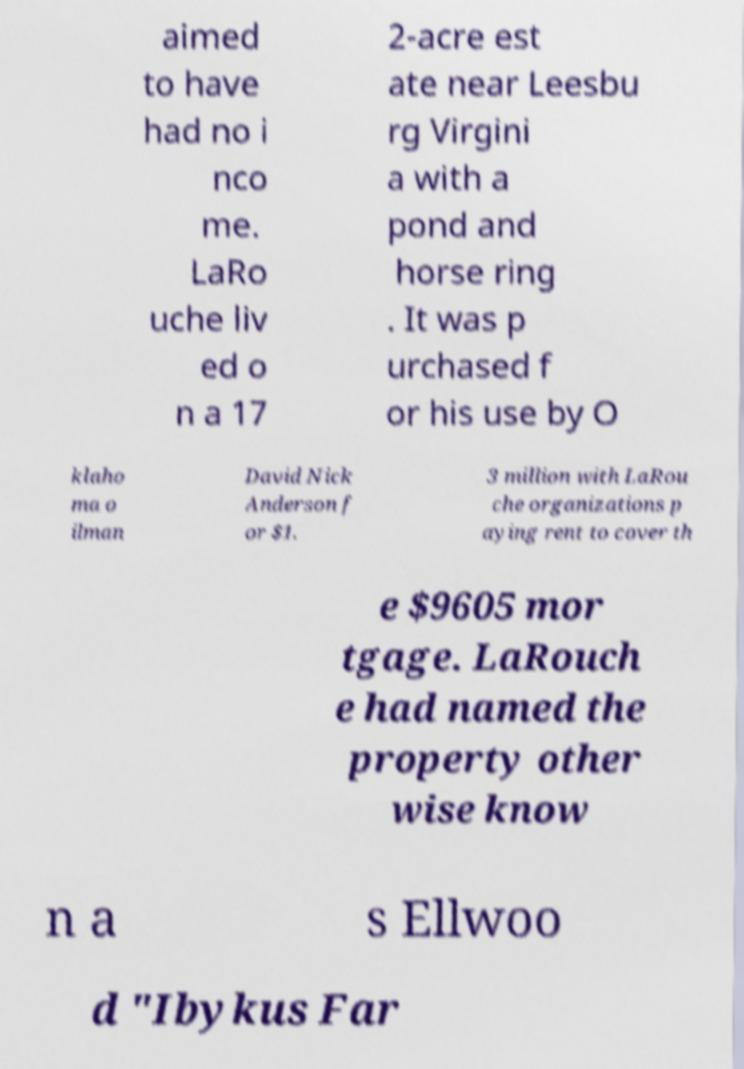Please read and relay the text visible in this image. What does it say? aimed to have had no i nco me. LaRo uche liv ed o n a 17 2-acre est ate near Leesbu rg Virgini a with a pond and horse ring . It was p urchased f or his use by O klaho ma o ilman David Nick Anderson f or $1. 3 million with LaRou che organizations p aying rent to cover th e $9605 mor tgage. LaRouch e had named the property other wise know n a s Ellwoo d "Ibykus Far 